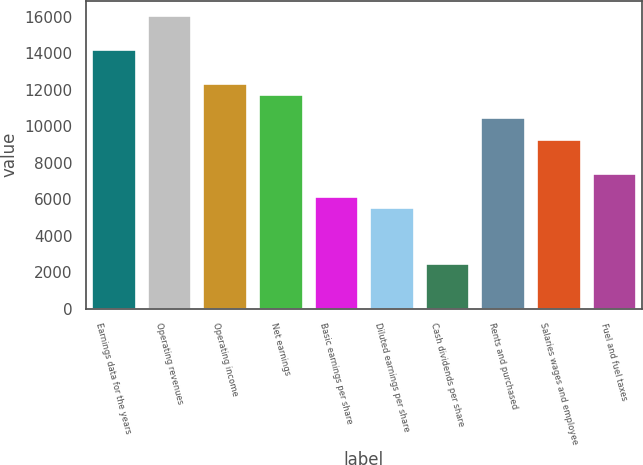Convert chart to OTSL. <chart><loc_0><loc_0><loc_500><loc_500><bar_chart><fcel>Earnings data for the years<fcel>Operating revenues<fcel>Operating income<fcel>Net earnings<fcel>Basic earnings per share<fcel>Diluted earnings per share<fcel>Cash dividends per share<fcel>Rents and purchased<fcel>Salaries wages and employee<fcel>Fuel and fuel taxes<nl><fcel>14232<fcel>16088.3<fcel>12375.7<fcel>11756.9<fcel>6188<fcel>5569.23<fcel>2475.38<fcel>10519.4<fcel>9281.85<fcel>7425.54<nl></chart> 